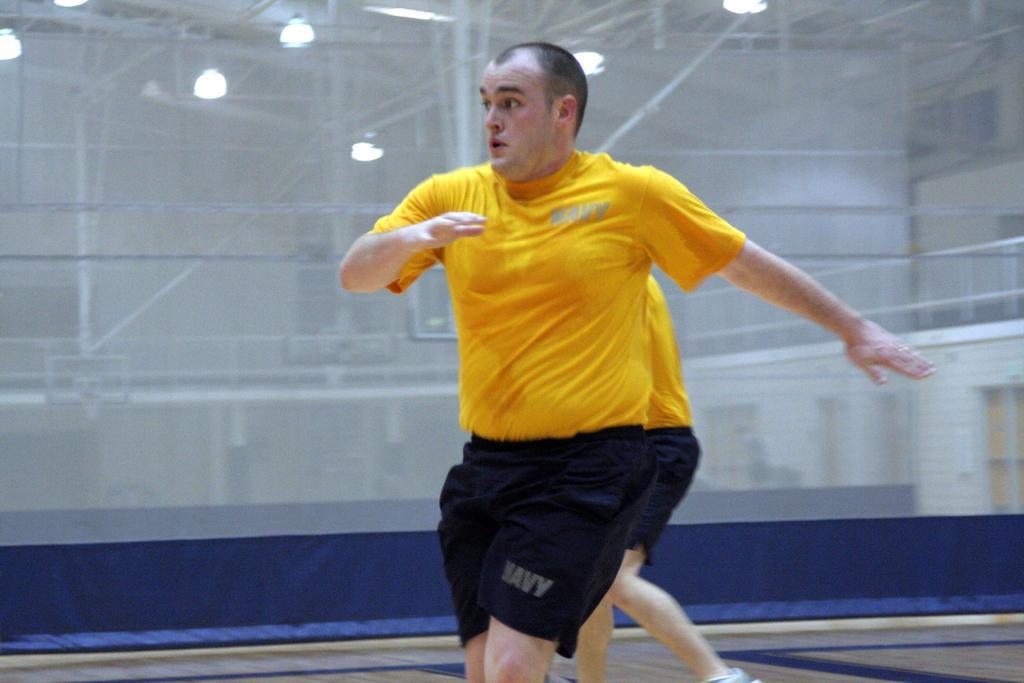How would you summarize this image in a sentence or two? There are two persons present in the middle of this image. We can see a curtain in the background. We can see lights and poles through this curtain. 